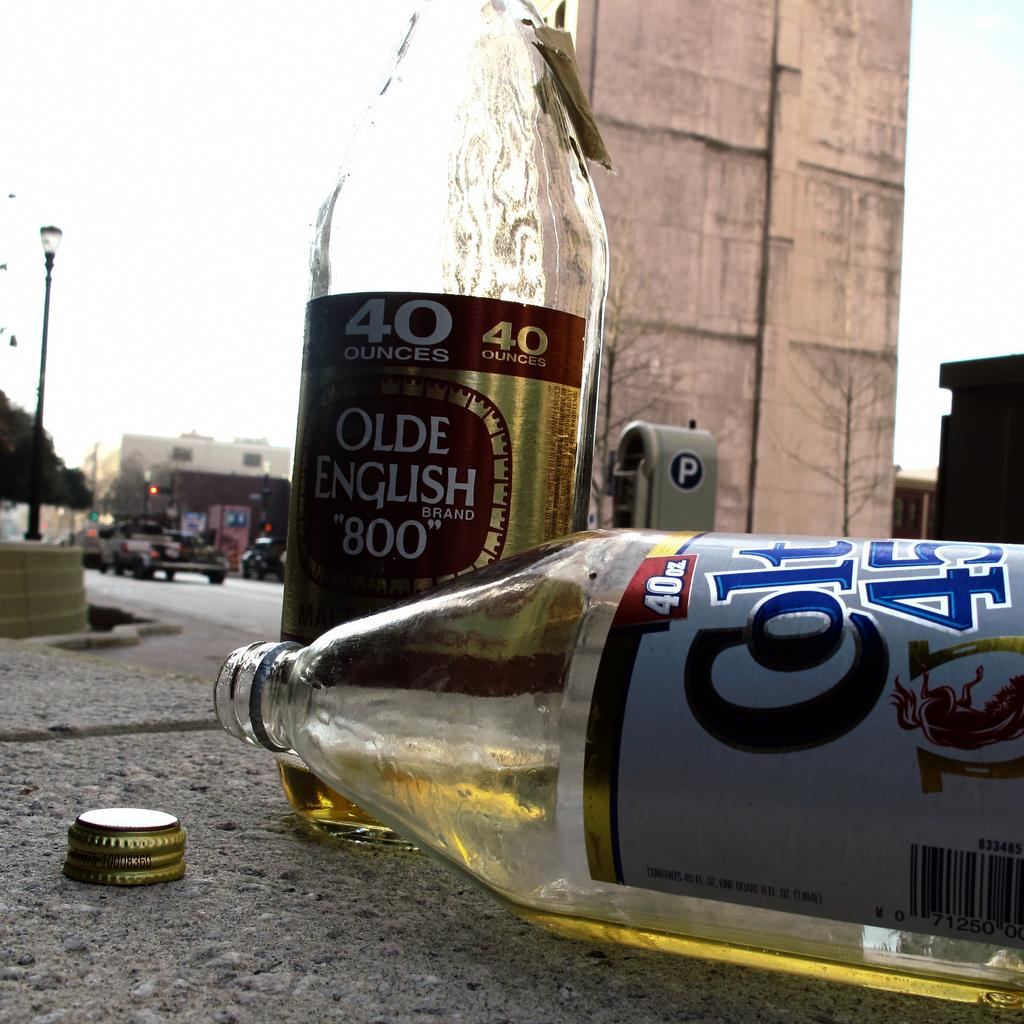<image>
Give a short and clear explanation of the subsequent image. A bottle of Colt 45 is laying sideways on the ground next to an upright bottle of Olde English "800." 